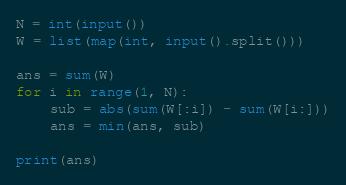<code> <loc_0><loc_0><loc_500><loc_500><_Python_>N = int(input())
W = list(map(int, input().split()))

ans = sum(W)
for i in range(1, N):
	sub = abs(sum(W[:i]) - sum(W[i:]))
	ans = min(ans, sub)

print(ans)</code> 